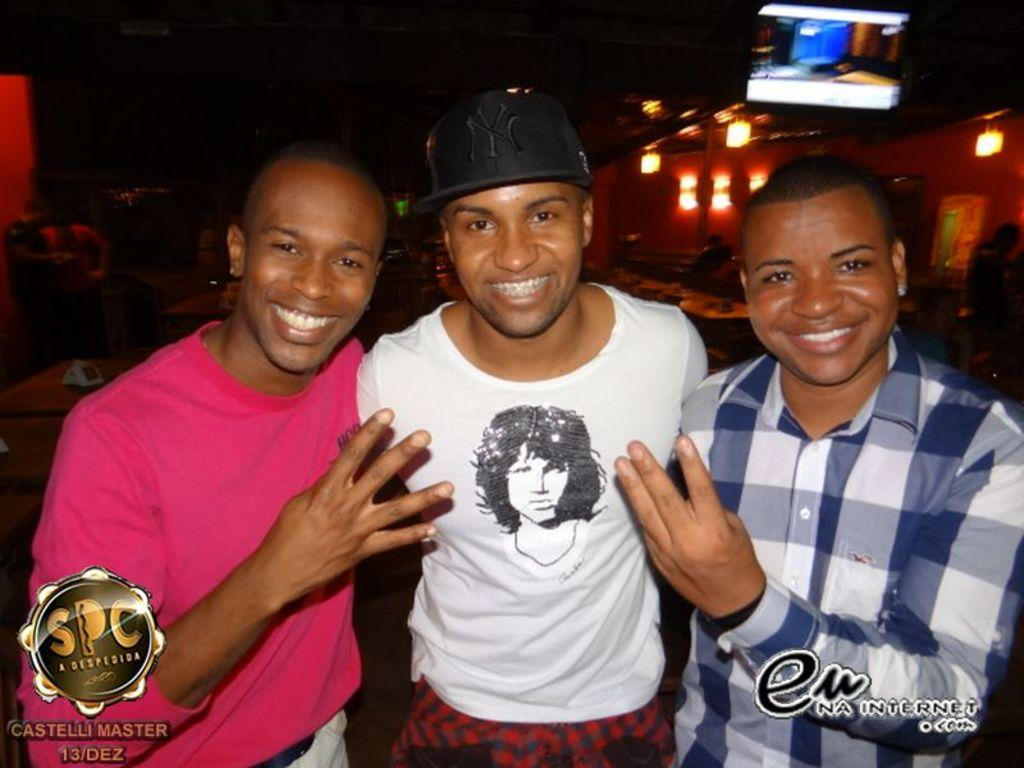What can be seen in the image involving people? There are people standing in the image. What is visible in the background of the image? There is a wall with lights in the background. What type of furniture is present in the image? There are chairs and tables in the image. Can you describe the object at the top of the image? Unfortunately, the facts provided do not give any information about the object at the top of the image. What type of substance is being rewarded in the image according to the theory? There is no substance, reward, or theory mentioned in the image, so this question cannot be answered definitively. 